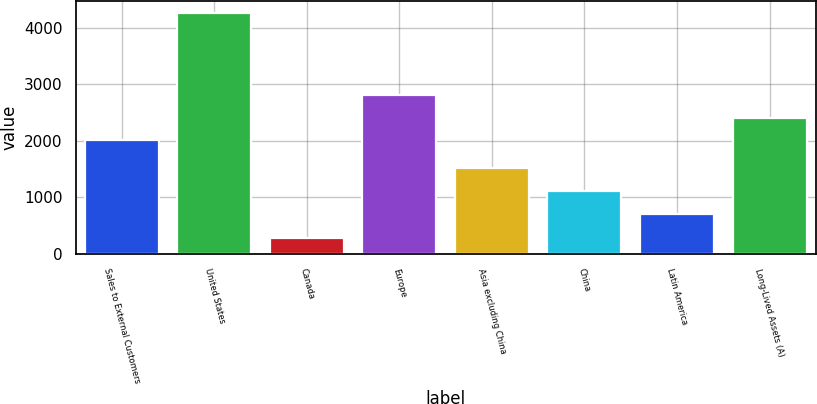Convert chart. <chart><loc_0><loc_0><loc_500><loc_500><bar_chart><fcel>Sales to External Customers<fcel>United States<fcel>Canada<fcel>Europe<fcel>Asia excluding China<fcel>China<fcel>Latin America<fcel>Long-Lived Assets (A)<nl><fcel>2013<fcel>4258.4<fcel>275.5<fcel>2809.58<fcel>1512.58<fcel>1114.29<fcel>716<fcel>2411.29<nl></chart> 